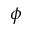Convert formula to latex. <formula><loc_0><loc_0><loc_500><loc_500>\phi</formula> 